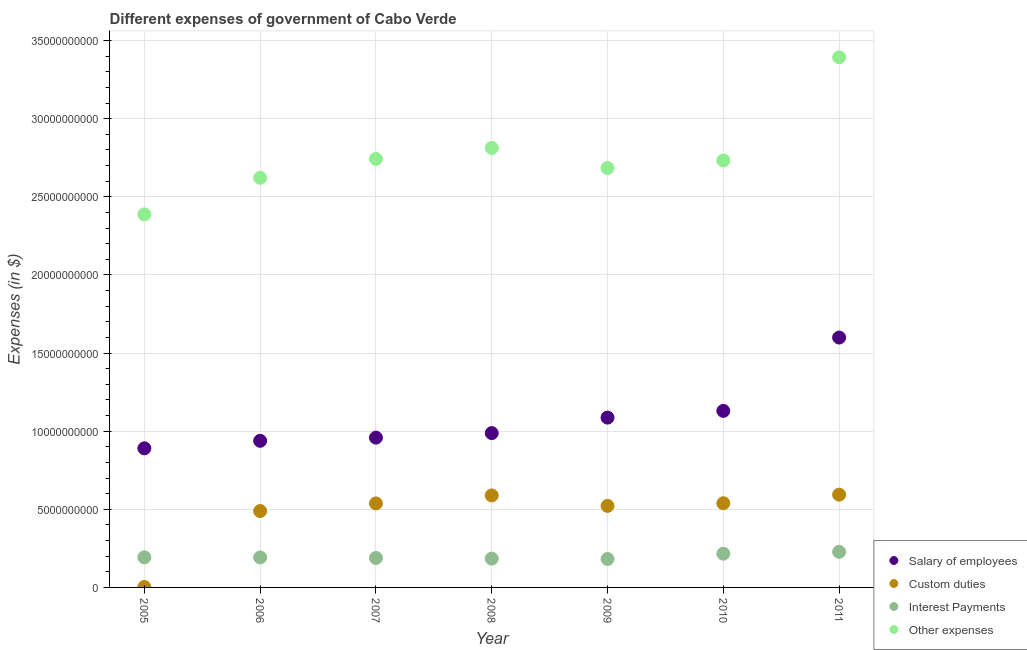Is the number of dotlines equal to the number of legend labels?
Give a very brief answer. Yes. What is the amount spent on interest payments in 2005?
Provide a short and direct response. 1.93e+09. Across all years, what is the maximum amount spent on salary of employees?
Give a very brief answer. 1.60e+1. Across all years, what is the minimum amount spent on custom duties?
Provide a succinct answer. 2.89e+07. In which year was the amount spent on other expenses minimum?
Give a very brief answer. 2005. What is the total amount spent on salary of employees in the graph?
Provide a succinct answer. 7.59e+1. What is the difference between the amount spent on custom duties in 2007 and that in 2011?
Make the answer very short. -5.61e+08. What is the difference between the amount spent on salary of employees in 2006 and the amount spent on interest payments in 2009?
Provide a short and direct response. 7.57e+09. What is the average amount spent on interest payments per year?
Your response must be concise. 1.98e+09. In the year 2006, what is the difference between the amount spent on interest payments and amount spent on custom duties?
Keep it short and to the point. -2.97e+09. What is the ratio of the amount spent on salary of employees in 2007 to that in 2010?
Keep it short and to the point. 0.85. Is the amount spent on other expenses in 2007 less than that in 2010?
Your answer should be compact. No. Is the difference between the amount spent on other expenses in 2007 and 2009 greater than the difference between the amount spent on custom duties in 2007 and 2009?
Offer a terse response. Yes. What is the difference between the highest and the second highest amount spent on salary of employees?
Offer a terse response. 4.70e+09. What is the difference between the highest and the lowest amount spent on interest payments?
Offer a terse response. 4.58e+08. Is the sum of the amount spent on custom duties in 2006 and 2009 greater than the maximum amount spent on interest payments across all years?
Your answer should be compact. Yes. Is it the case that in every year, the sum of the amount spent on salary of employees and amount spent on custom duties is greater than the amount spent on interest payments?
Give a very brief answer. Yes. Does the amount spent on custom duties monotonically increase over the years?
Your answer should be compact. No. Is the amount spent on custom duties strictly less than the amount spent on other expenses over the years?
Your answer should be very brief. Yes. What is the difference between two consecutive major ticks on the Y-axis?
Your response must be concise. 5.00e+09. Are the values on the major ticks of Y-axis written in scientific E-notation?
Ensure brevity in your answer.  No. Does the graph contain any zero values?
Keep it short and to the point. No. Where does the legend appear in the graph?
Your answer should be compact. Bottom right. How many legend labels are there?
Provide a succinct answer. 4. What is the title of the graph?
Your answer should be very brief. Different expenses of government of Cabo Verde. What is the label or title of the X-axis?
Give a very brief answer. Year. What is the label or title of the Y-axis?
Your response must be concise. Expenses (in $). What is the Expenses (in $) of Salary of employees in 2005?
Provide a succinct answer. 8.90e+09. What is the Expenses (in $) of Custom duties in 2005?
Keep it short and to the point. 2.89e+07. What is the Expenses (in $) of Interest Payments in 2005?
Your response must be concise. 1.93e+09. What is the Expenses (in $) in Other expenses in 2005?
Provide a short and direct response. 2.39e+1. What is the Expenses (in $) in Salary of employees in 2006?
Offer a terse response. 9.38e+09. What is the Expenses (in $) in Custom duties in 2006?
Your answer should be compact. 4.89e+09. What is the Expenses (in $) of Interest Payments in 2006?
Keep it short and to the point. 1.92e+09. What is the Expenses (in $) of Other expenses in 2006?
Your answer should be compact. 2.62e+1. What is the Expenses (in $) of Salary of employees in 2007?
Provide a succinct answer. 9.59e+09. What is the Expenses (in $) in Custom duties in 2007?
Provide a short and direct response. 5.38e+09. What is the Expenses (in $) of Interest Payments in 2007?
Your answer should be very brief. 1.89e+09. What is the Expenses (in $) of Other expenses in 2007?
Ensure brevity in your answer.  2.74e+1. What is the Expenses (in $) in Salary of employees in 2008?
Your answer should be very brief. 9.88e+09. What is the Expenses (in $) in Custom duties in 2008?
Give a very brief answer. 5.89e+09. What is the Expenses (in $) of Interest Payments in 2008?
Provide a short and direct response. 1.85e+09. What is the Expenses (in $) of Other expenses in 2008?
Provide a short and direct response. 2.81e+1. What is the Expenses (in $) in Salary of employees in 2009?
Ensure brevity in your answer.  1.09e+1. What is the Expenses (in $) in Custom duties in 2009?
Your answer should be very brief. 5.22e+09. What is the Expenses (in $) in Interest Payments in 2009?
Your response must be concise. 1.82e+09. What is the Expenses (in $) of Other expenses in 2009?
Ensure brevity in your answer.  2.68e+1. What is the Expenses (in $) in Salary of employees in 2010?
Provide a succinct answer. 1.13e+1. What is the Expenses (in $) of Custom duties in 2010?
Ensure brevity in your answer.  5.39e+09. What is the Expenses (in $) of Interest Payments in 2010?
Provide a short and direct response. 2.16e+09. What is the Expenses (in $) in Other expenses in 2010?
Provide a short and direct response. 2.73e+1. What is the Expenses (in $) of Salary of employees in 2011?
Your answer should be compact. 1.60e+1. What is the Expenses (in $) in Custom duties in 2011?
Your response must be concise. 5.94e+09. What is the Expenses (in $) in Interest Payments in 2011?
Offer a very short reply. 2.28e+09. What is the Expenses (in $) in Other expenses in 2011?
Keep it short and to the point. 3.39e+1. Across all years, what is the maximum Expenses (in $) in Salary of employees?
Give a very brief answer. 1.60e+1. Across all years, what is the maximum Expenses (in $) of Custom duties?
Offer a terse response. 5.94e+09. Across all years, what is the maximum Expenses (in $) in Interest Payments?
Your answer should be compact. 2.28e+09. Across all years, what is the maximum Expenses (in $) in Other expenses?
Your response must be concise. 3.39e+1. Across all years, what is the minimum Expenses (in $) of Salary of employees?
Your answer should be very brief. 8.90e+09. Across all years, what is the minimum Expenses (in $) in Custom duties?
Offer a terse response. 2.89e+07. Across all years, what is the minimum Expenses (in $) of Interest Payments?
Offer a terse response. 1.82e+09. Across all years, what is the minimum Expenses (in $) of Other expenses?
Provide a short and direct response. 2.39e+1. What is the total Expenses (in $) in Salary of employees in the graph?
Your answer should be compact. 7.59e+1. What is the total Expenses (in $) in Custom duties in the graph?
Keep it short and to the point. 3.27e+1. What is the total Expenses (in $) in Interest Payments in the graph?
Your answer should be very brief. 1.38e+1. What is the total Expenses (in $) of Other expenses in the graph?
Your answer should be very brief. 1.94e+11. What is the difference between the Expenses (in $) of Salary of employees in 2005 and that in 2006?
Keep it short and to the point. -4.81e+08. What is the difference between the Expenses (in $) of Custom duties in 2005 and that in 2006?
Provide a short and direct response. -4.86e+09. What is the difference between the Expenses (in $) in Interest Payments in 2005 and that in 2006?
Give a very brief answer. 7.14e+06. What is the difference between the Expenses (in $) of Other expenses in 2005 and that in 2006?
Make the answer very short. -2.34e+09. What is the difference between the Expenses (in $) of Salary of employees in 2005 and that in 2007?
Provide a short and direct response. -6.84e+08. What is the difference between the Expenses (in $) of Custom duties in 2005 and that in 2007?
Your answer should be very brief. -5.35e+09. What is the difference between the Expenses (in $) of Interest Payments in 2005 and that in 2007?
Your answer should be very brief. 4.18e+07. What is the difference between the Expenses (in $) of Other expenses in 2005 and that in 2007?
Provide a succinct answer. -3.55e+09. What is the difference between the Expenses (in $) in Salary of employees in 2005 and that in 2008?
Provide a succinct answer. -9.74e+08. What is the difference between the Expenses (in $) of Custom duties in 2005 and that in 2008?
Your answer should be compact. -5.86e+09. What is the difference between the Expenses (in $) of Interest Payments in 2005 and that in 2008?
Your answer should be compact. 8.17e+07. What is the difference between the Expenses (in $) in Other expenses in 2005 and that in 2008?
Your response must be concise. -4.25e+09. What is the difference between the Expenses (in $) in Salary of employees in 2005 and that in 2009?
Make the answer very short. -1.97e+09. What is the difference between the Expenses (in $) in Custom duties in 2005 and that in 2009?
Provide a succinct answer. -5.19e+09. What is the difference between the Expenses (in $) of Interest Payments in 2005 and that in 2009?
Keep it short and to the point. 1.09e+08. What is the difference between the Expenses (in $) in Other expenses in 2005 and that in 2009?
Give a very brief answer. -2.97e+09. What is the difference between the Expenses (in $) of Salary of employees in 2005 and that in 2010?
Ensure brevity in your answer.  -2.39e+09. What is the difference between the Expenses (in $) of Custom duties in 2005 and that in 2010?
Offer a terse response. -5.36e+09. What is the difference between the Expenses (in $) in Interest Payments in 2005 and that in 2010?
Keep it short and to the point. -2.32e+08. What is the difference between the Expenses (in $) of Other expenses in 2005 and that in 2010?
Ensure brevity in your answer.  -3.45e+09. What is the difference between the Expenses (in $) in Salary of employees in 2005 and that in 2011?
Offer a terse response. -7.09e+09. What is the difference between the Expenses (in $) of Custom duties in 2005 and that in 2011?
Your answer should be compact. -5.91e+09. What is the difference between the Expenses (in $) of Interest Payments in 2005 and that in 2011?
Make the answer very short. -3.49e+08. What is the difference between the Expenses (in $) of Other expenses in 2005 and that in 2011?
Your answer should be compact. -1.01e+1. What is the difference between the Expenses (in $) in Salary of employees in 2006 and that in 2007?
Offer a very short reply. -2.03e+08. What is the difference between the Expenses (in $) in Custom duties in 2006 and that in 2007?
Keep it short and to the point. -4.88e+08. What is the difference between the Expenses (in $) in Interest Payments in 2006 and that in 2007?
Provide a short and direct response. 3.47e+07. What is the difference between the Expenses (in $) of Other expenses in 2006 and that in 2007?
Offer a very short reply. -1.21e+09. What is the difference between the Expenses (in $) in Salary of employees in 2006 and that in 2008?
Provide a short and direct response. -4.93e+08. What is the difference between the Expenses (in $) in Custom duties in 2006 and that in 2008?
Give a very brief answer. -9.99e+08. What is the difference between the Expenses (in $) of Interest Payments in 2006 and that in 2008?
Your answer should be very brief. 7.45e+07. What is the difference between the Expenses (in $) in Other expenses in 2006 and that in 2008?
Ensure brevity in your answer.  -1.91e+09. What is the difference between the Expenses (in $) in Salary of employees in 2006 and that in 2009?
Your answer should be very brief. -1.49e+09. What is the difference between the Expenses (in $) of Custom duties in 2006 and that in 2009?
Your answer should be compact. -3.30e+08. What is the difference between the Expenses (in $) in Interest Payments in 2006 and that in 2009?
Provide a short and direct response. 1.02e+08. What is the difference between the Expenses (in $) in Other expenses in 2006 and that in 2009?
Make the answer very short. -6.27e+08. What is the difference between the Expenses (in $) in Salary of employees in 2006 and that in 2010?
Your response must be concise. -1.91e+09. What is the difference between the Expenses (in $) in Custom duties in 2006 and that in 2010?
Your response must be concise. -5.00e+08. What is the difference between the Expenses (in $) in Interest Payments in 2006 and that in 2010?
Provide a succinct answer. -2.39e+08. What is the difference between the Expenses (in $) of Other expenses in 2006 and that in 2010?
Give a very brief answer. -1.11e+09. What is the difference between the Expenses (in $) of Salary of employees in 2006 and that in 2011?
Provide a short and direct response. -6.61e+09. What is the difference between the Expenses (in $) of Custom duties in 2006 and that in 2011?
Offer a very short reply. -1.05e+09. What is the difference between the Expenses (in $) in Interest Payments in 2006 and that in 2011?
Make the answer very short. -3.56e+08. What is the difference between the Expenses (in $) in Other expenses in 2006 and that in 2011?
Provide a succinct answer. -7.71e+09. What is the difference between the Expenses (in $) of Salary of employees in 2007 and that in 2008?
Provide a short and direct response. -2.90e+08. What is the difference between the Expenses (in $) of Custom duties in 2007 and that in 2008?
Ensure brevity in your answer.  -5.12e+08. What is the difference between the Expenses (in $) of Interest Payments in 2007 and that in 2008?
Keep it short and to the point. 3.98e+07. What is the difference between the Expenses (in $) of Other expenses in 2007 and that in 2008?
Provide a succinct answer. -7.00e+08. What is the difference between the Expenses (in $) of Salary of employees in 2007 and that in 2009?
Make the answer very short. -1.28e+09. What is the difference between the Expenses (in $) in Custom duties in 2007 and that in 2009?
Offer a very short reply. 1.57e+08. What is the difference between the Expenses (in $) of Interest Payments in 2007 and that in 2009?
Provide a succinct answer. 6.70e+07. What is the difference between the Expenses (in $) in Other expenses in 2007 and that in 2009?
Give a very brief answer. 5.83e+08. What is the difference between the Expenses (in $) of Salary of employees in 2007 and that in 2010?
Provide a short and direct response. -1.71e+09. What is the difference between the Expenses (in $) in Custom duties in 2007 and that in 2010?
Give a very brief answer. -1.21e+07. What is the difference between the Expenses (in $) in Interest Payments in 2007 and that in 2010?
Ensure brevity in your answer.  -2.74e+08. What is the difference between the Expenses (in $) in Other expenses in 2007 and that in 2010?
Offer a terse response. 1.01e+08. What is the difference between the Expenses (in $) of Salary of employees in 2007 and that in 2011?
Offer a terse response. -6.41e+09. What is the difference between the Expenses (in $) of Custom duties in 2007 and that in 2011?
Ensure brevity in your answer.  -5.61e+08. What is the difference between the Expenses (in $) of Interest Payments in 2007 and that in 2011?
Your answer should be compact. -3.91e+08. What is the difference between the Expenses (in $) in Other expenses in 2007 and that in 2011?
Give a very brief answer. -6.50e+09. What is the difference between the Expenses (in $) of Salary of employees in 2008 and that in 2009?
Your answer should be very brief. -9.92e+08. What is the difference between the Expenses (in $) in Custom duties in 2008 and that in 2009?
Keep it short and to the point. 6.69e+08. What is the difference between the Expenses (in $) of Interest Payments in 2008 and that in 2009?
Provide a succinct answer. 2.72e+07. What is the difference between the Expenses (in $) in Other expenses in 2008 and that in 2009?
Your response must be concise. 1.28e+09. What is the difference between the Expenses (in $) in Salary of employees in 2008 and that in 2010?
Make the answer very short. -1.42e+09. What is the difference between the Expenses (in $) in Custom duties in 2008 and that in 2010?
Give a very brief answer. 5.00e+08. What is the difference between the Expenses (in $) of Interest Payments in 2008 and that in 2010?
Offer a terse response. -3.14e+08. What is the difference between the Expenses (in $) of Other expenses in 2008 and that in 2010?
Provide a succinct answer. 8.02e+08. What is the difference between the Expenses (in $) in Salary of employees in 2008 and that in 2011?
Your answer should be compact. -6.12e+09. What is the difference between the Expenses (in $) of Custom duties in 2008 and that in 2011?
Give a very brief answer. -4.94e+07. What is the difference between the Expenses (in $) of Interest Payments in 2008 and that in 2011?
Your response must be concise. -4.31e+08. What is the difference between the Expenses (in $) of Other expenses in 2008 and that in 2011?
Provide a short and direct response. -5.80e+09. What is the difference between the Expenses (in $) in Salary of employees in 2009 and that in 2010?
Your answer should be compact. -4.29e+08. What is the difference between the Expenses (in $) of Custom duties in 2009 and that in 2010?
Ensure brevity in your answer.  -1.69e+08. What is the difference between the Expenses (in $) of Interest Payments in 2009 and that in 2010?
Provide a succinct answer. -3.41e+08. What is the difference between the Expenses (in $) in Other expenses in 2009 and that in 2010?
Offer a terse response. -4.81e+08. What is the difference between the Expenses (in $) of Salary of employees in 2009 and that in 2011?
Offer a terse response. -5.12e+09. What is the difference between the Expenses (in $) of Custom duties in 2009 and that in 2011?
Provide a succinct answer. -7.19e+08. What is the difference between the Expenses (in $) of Interest Payments in 2009 and that in 2011?
Provide a short and direct response. -4.58e+08. What is the difference between the Expenses (in $) of Other expenses in 2009 and that in 2011?
Ensure brevity in your answer.  -7.08e+09. What is the difference between the Expenses (in $) of Salary of employees in 2010 and that in 2011?
Your answer should be compact. -4.70e+09. What is the difference between the Expenses (in $) of Custom duties in 2010 and that in 2011?
Give a very brief answer. -5.49e+08. What is the difference between the Expenses (in $) in Interest Payments in 2010 and that in 2011?
Offer a terse response. -1.17e+08. What is the difference between the Expenses (in $) in Other expenses in 2010 and that in 2011?
Ensure brevity in your answer.  -6.60e+09. What is the difference between the Expenses (in $) of Salary of employees in 2005 and the Expenses (in $) of Custom duties in 2006?
Offer a terse response. 4.01e+09. What is the difference between the Expenses (in $) in Salary of employees in 2005 and the Expenses (in $) in Interest Payments in 2006?
Provide a succinct answer. 6.98e+09. What is the difference between the Expenses (in $) of Salary of employees in 2005 and the Expenses (in $) of Other expenses in 2006?
Your answer should be very brief. -1.73e+1. What is the difference between the Expenses (in $) in Custom duties in 2005 and the Expenses (in $) in Interest Payments in 2006?
Your answer should be very brief. -1.89e+09. What is the difference between the Expenses (in $) in Custom duties in 2005 and the Expenses (in $) in Other expenses in 2006?
Make the answer very short. -2.62e+1. What is the difference between the Expenses (in $) in Interest Payments in 2005 and the Expenses (in $) in Other expenses in 2006?
Provide a succinct answer. -2.43e+1. What is the difference between the Expenses (in $) in Salary of employees in 2005 and the Expenses (in $) in Custom duties in 2007?
Your response must be concise. 3.53e+09. What is the difference between the Expenses (in $) of Salary of employees in 2005 and the Expenses (in $) of Interest Payments in 2007?
Your response must be concise. 7.02e+09. What is the difference between the Expenses (in $) in Salary of employees in 2005 and the Expenses (in $) in Other expenses in 2007?
Provide a short and direct response. -1.85e+1. What is the difference between the Expenses (in $) of Custom duties in 2005 and the Expenses (in $) of Interest Payments in 2007?
Offer a very short reply. -1.86e+09. What is the difference between the Expenses (in $) of Custom duties in 2005 and the Expenses (in $) of Other expenses in 2007?
Make the answer very short. -2.74e+1. What is the difference between the Expenses (in $) of Interest Payments in 2005 and the Expenses (in $) of Other expenses in 2007?
Provide a succinct answer. -2.55e+1. What is the difference between the Expenses (in $) in Salary of employees in 2005 and the Expenses (in $) in Custom duties in 2008?
Make the answer very short. 3.02e+09. What is the difference between the Expenses (in $) of Salary of employees in 2005 and the Expenses (in $) of Interest Payments in 2008?
Offer a very short reply. 7.06e+09. What is the difference between the Expenses (in $) of Salary of employees in 2005 and the Expenses (in $) of Other expenses in 2008?
Offer a very short reply. -1.92e+1. What is the difference between the Expenses (in $) in Custom duties in 2005 and the Expenses (in $) in Interest Payments in 2008?
Your response must be concise. -1.82e+09. What is the difference between the Expenses (in $) of Custom duties in 2005 and the Expenses (in $) of Other expenses in 2008?
Your answer should be compact. -2.81e+1. What is the difference between the Expenses (in $) in Interest Payments in 2005 and the Expenses (in $) in Other expenses in 2008?
Provide a succinct answer. -2.62e+1. What is the difference between the Expenses (in $) of Salary of employees in 2005 and the Expenses (in $) of Custom duties in 2009?
Ensure brevity in your answer.  3.68e+09. What is the difference between the Expenses (in $) of Salary of employees in 2005 and the Expenses (in $) of Interest Payments in 2009?
Make the answer very short. 7.09e+09. What is the difference between the Expenses (in $) of Salary of employees in 2005 and the Expenses (in $) of Other expenses in 2009?
Keep it short and to the point. -1.79e+1. What is the difference between the Expenses (in $) of Custom duties in 2005 and the Expenses (in $) of Interest Payments in 2009?
Offer a terse response. -1.79e+09. What is the difference between the Expenses (in $) of Custom duties in 2005 and the Expenses (in $) of Other expenses in 2009?
Provide a short and direct response. -2.68e+1. What is the difference between the Expenses (in $) of Interest Payments in 2005 and the Expenses (in $) of Other expenses in 2009?
Provide a short and direct response. -2.49e+1. What is the difference between the Expenses (in $) of Salary of employees in 2005 and the Expenses (in $) of Custom duties in 2010?
Offer a very short reply. 3.51e+09. What is the difference between the Expenses (in $) of Salary of employees in 2005 and the Expenses (in $) of Interest Payments in 2010?
Your answer should be very brief. 6.74e+09. What is the difference between the Expenses (in $) of Salary of employees in 2005 and the Expenses (in $) of Other expenses in 2010?
Ensure brevity in your answer.  -1.84e+1. What is the difference between the Expenses (in $) in Custom duties in 2005 and the Expenses (in $) in Interest Payments in 2010?
Make the answer very short. -2.13e+09. What is the difference between the Expenses (in $) in Custom duties in 2005 and the Expenses (in $) in Other expenses in 2010?
Offer a terse response. -2.73e+1. What is the difference between the Expenses (in $) in Interest Payments in 2005 and the Expenses (in $) in Other expenses in 2010?
Your answer should be very brief. -2.54e+1. What is the difference between the Expenses (in $) of Salary of employees in 2005 and the Expenses (in $) of Custom duties in 2011?
Offer a terse response. 2.97e+09. What is the difference between the Expenses (in $) of Salary of employees in 2005 and the Expenses (in $) of Interest Payments in 2011?
Your response must be concise. 6.63e+09. What is the difference between the Expenses (in $) of Salary of employees in 2005 and the Expenses (in $) of Other expenses in 2011?
Provide a short and direct response. -2.50e+1. What is the difference between the Expenses (in $) in Custom duties in 2005 and the Expenses (in $) in Interest Payments in 2011?
Your answer should be very brief. -2.25e+09. What is the difference between the Expenses (in $) in Custom duties in 2005 and the Expenses (in $) in Other expenses in 2011?
Make the answer very short. -3.39e+1. What is the difference between the Expenses (in $) of Interest Payments in 2005 and the Expenses (in $) of Other expenses in 2011?
Offer a terse response. -3.20e+1. What is the difference between the Expenses (in $) in Salary of employees in 2006 and the Expenses (in $) in Custom duties in 2007?
Your response must be concise. 4.01e+09. What is the difference between the Expenses (in $) in Salary of employees in 2006 and the Expenses (in $) in Interest Payments in 2007?
Your answer should be compact. 7.50e+09. What is the difference between the Expenses (in $) in Salary of employees in 2006 and the Expenses (in $) in Other expenses in 2007?
Ensure brevity in your answer.  -1.80e+1. What is the difference between the Expenses (in $) of Custom duties in 2006 and the Expenses (in $) of Interest Payments in 2007?
Keep it short and to the point. 3.00e+09. What is the difference between the Expenses (in $) of Custom duties in 2006 and the Expenses (in $) of Other expenses in 2007?
Keep it short and to the point. -2.25e+1. What is the difference between the Expenses (in $) of Interest Payments in 2006 and the Expenses (in $) of Other expenses in 2007?
Keep it short and to the point. -2.55e+1. What is the difference between the Expenses (in $) in Salary of employees in 2006 and the Expenses (in $) in Custom duties in 2008?
Your response must be concise. 3.50e+09. What is the difference between the Expenses (in $) in Salary of employees in 2006 and the Expenses (in $) in Interest Payments in 2008?
Make the answer very short. 7.54e+09. What is the difference between the Expenses (in $) of Salary of employees in 2006 and the Expenses (in $) of Other expenses in 2008?
Your response must be concise. -1.87e+1. What is the difference between the Expenses (in $) in Custom duties in 2006 and the Expenses (in $) in Interest Payments in 2008?
Make the answer very short. 3.04e+09. What is the difference between the Expenses (in $) of Custom duties in 2006 and the Expenses (in $) of Other expenses in 2008?
Provide a short and direct response. -2.32e+1. What is the difference between the Expenses (in $) in Interest Payments in 2006 and the Expenses (in $) in Other expenses in 2008?
Offer a terse response. -2.62e+1. What is the difference between the Expenses (in $) in Salary of employees in 2006 and the Expenses (in $) in Custom duties in 2009?
Keep it short and to the point. 4.16e+09. What is the difference between the Expenses (in $) of Salary of employees in 2006 and the Expenses (in $) of Interest Payments in 2009?
Offer a very short reply. 7.57e+09. What is the difference between the Expenses (in $) in Salary of employees in 2006 and the Expenses (in $) in Other expenses in 2009?
Keep it short and to the point. -1.75e+1. What is the difference between the Expenses (in $) in Custom duties in 2006 and the Expenses (in $) in Interest Payments in 2009?
Offer a very short reply. 3.07e+09. What is the difference between the Expenses (in $) of Custom duties in 2006 and the Expenses (in $) of Other expenses in 2009?
Provide a succinct answer. -2.20e+1. What is the difference between the Expenses (in $) of Interest Payments in 2006 and the Expenses (in $) of Other expenses in 2009?
Your answer should be compact. -2.49e+1. What is the difference between the Expenses (in $) of Salary of employees in 2006 and the Expenses (in $) of Custom duties in 2010?
Your response must be concise. 4.00e+09. What is the difference between the Expenses (in $) in Salary of employees in 2006 and the Expenses (in $) in Interest Payments in 2010?
Provide a succinct answer. 7.22e+09. What is the difference between the Expenses (in $) in Salary of employees in 2006 and the Expenses (in $) in Other expenses in 2010?
Provide a short and direct response. -1.79e+1. What is the difference between the Expenses (in $) in Custom duties in 2006 and the Expenses (in $) in Interest Payments in 2010?
Make the answer very short. 2.73e+09. What is the difference between the Expenses (in $) of Custom duties in 2006 and the Expenses (in $) of Other expenses in 2010?
Offer a terse response. -2.24e+1. What is the difference between the Expenses (in $) in Interest Payments in 2006 and the Expenses (in $) in Other expenses in 2010?
Give a very brief answer. -2.54e+1. What is the difference between the Expenses (in $) of Salary of employees in 2006 and the Expenses (in $) of Custom duties in 2011?
Your response must be concise. 3.45e+09. What is the difference between the Expenses (in $) of Salary of employees in 2006 and the Expenses (in $) of Interest Payments in 2011?
Offer a terse response. 7.11e+09. What is the difference between the Expenses (in $) of Salary of employees in 2006 and the Expenses (in $) of Other expenses in 2011?
Give a very brief answer. -2.45e+1. What is the difference between the Expenses (in $) in Custom duties in 2006 and the Expenses (in $) in Interest Payments in 2011?
Give a very brief answer. 2.61e+09. What is the difference between the Expenses (in $) in Custom duties in 2006 and the Expenses (in $) in Other expenses in 2011?
Ensure brevity in your answer.  -2.90e+1. What is the difference between the Expenses (in $) in Interest Payments in 2006 and the Expenses (in $) in Other expenses in 2011?
Your answer should be very brief. -3.20e+1. What is the difference between the Expenses (in $) in Salary of employees in 2007 and the Expenses (in $) in Custom duties in 2008?
Provide a short and direct response. 3.70e+09. What is the difference between the Expenses (in $) in Salary of employees in 2007 and the Expenses (in $) in Interest Payments in 2008?
Your answer should be compact. 7.74e+09. What is the difference between the Expenses (in $) of Salary of employees in 2007 and the Expenses (in $) of Other expenses in 2008?
Your answer should be compact. -1.85e+1. What is the difference between the Expenses (in $) in Custom duties in 2007 and the Expenses (in $) in Interest Payments in 2008?
Provide a short and direct response. 3.53e+09. What is the difference between the Expenses (in $) of Custom duties in 2007 and the Expenses (in $) of Other expenses in 2008?
Make the answer very short. -2.28e+1. What is the difference between the Expenses (in $) of Interest Payments in 2007 and the Expenses (in $) of Other expenses in 2008?
Offer a terse response. -2.62e+1. What is the difference between the Expenses (in $) of Salary of employees in 2007 and the Expenses (in $) of Custom duties in 2009?
Provide a short and direct response. 4.37e+09. What is the difference between the Expenses (in $) in Salary of employees in 2007 and the Expenses (in $) in Interest Payments in 2009?
Ensure brevity in your answer.  7.77e+09. What is the difference between the Expenses (in $) in Salary of employees in 2007 and the Expenses (in $) in Other expenses in 2009?
Keep it short and to the point. -1.73e+1. What is the difference between the Expenses (in $) in Custom duties in 2007 and the Expenses (in $) in Interest Payments in 2009?
Keep it short and to the point. 3.56e+09. What is the difference between the Expenses (in $) in Custom duties in 2007 and the Expenses (in $) in Other expenses in 2009?
Make the answer very short. -2.15e+1. What is the difference between the Expenses (in $) in Interest Payments in 2007 and the Expenses (in $) in Other expenses in 2009?
Your answer should be compact. -2.50e+1. What is the difference between the Expenses (in $) in Salary of employees in 2007 and the Expenses (in $) in Custom duties in 2010?
Your answer should be compact. 4.20e+09. What is the difference between the Expenses (in $) of Salary of employees in 2007 and the Expenses (in $) of Interest Payments in 2010?
Keep it short and to the point. 7.43e+09. What is the difference between the Expenses (in $) in Salary of employees in 2007 and the Expenses (in $) in Other expenses in 2010?
Make the answer very short. -1.77e+1. What is the difference between the Expenses (in $) in Custom duties in 2007 and the Expenses (in $) in Interest Payments in 2010?
Your answer should be very brief. 3.22e+09. What is the difference between the Expenses (in $) of Custom duties in 2007 and the Expenses (in $) of Other expenses in 2010?
Ensure brevity in your answer.  -2.19e+1. What is the difference between the Expenses (in $) of Interest Payments in 2007 and the Expenses (in $) of Other expenses in 2010?
Your answer should be very brief. -2.54e+1. What is the difference between the Expenses (in $) in Salary of employees in 2007 and the Expenses (in $) in Custom duties in 2011?
Provide a short and direct response. 3.65e+09. What is the difference between the Expenses (in $) in Salary of employees in 2007 and the Expenses (in $) in Interest Payments in 2011?
Ensure brevity in your answer.  7.31e+09. What is the difference between the Expenses (in $) of Salary of employees in 2007 and the Expenses (in $) of Other expenses in 2011?
Give a very brief answer. -2.43e+1. What is the difference between the Expenses (in $) in Custom duties in 2007 and the Expenses (in $) in Interest Payments in 2011?
Provide a short and direct response. 3.10e+09. What is the difference between the Expenses (in $) in Custom duties in 2007 and the Expenses (in $) in Other expenses in 2011?
Give a very brief answer. -2.86e+1. What is the difference between the Expenses (in $) in Interest Payments in 2007 and the Expenses (in $) in Other expenses in 2011?
Give a very brief answer. -3.20e+1. What is the difference between the Expenses (in $) of Salary of employees in 2008 and the Expenses (in $) of Custom duties in 2009?
Your response must be concise. 4.66e+09. What is the difference between the Expenses (in $) of Salary of employees in 2008 and the Expenses (in $) of Interest Payments in 2009?
Your response must be concise. 8.06e+09. What is the difference between the Expenses (in $) of Salary of employees in 2008 and the Expenses (in $) of Other expenses in 2009?
Provide a succinct answer. -1.70e+1. What is the difference between the Expenses (in $) of Custom duties in 2008 and the Expenses (in $) of Interest Payments in 2009?
Make the answer very short. 4.07e+09. What is the difference between the Expenses (in $) of Custom duties in 2008 and the Expenses (in $) of Other expenses in 2009?
Keep it short and to the point. -2.10e+1. What is the difference between the Expenses (in $) of Interest Payments in 2008 and the Expenses (in $) of Other expenses in 2009?
Offer a terse response. -2.50e+1. What is the difference between the Expenses (in $) in Salary of employees in 2008 and the Expenses (in $) in Custom duties in 2010?
Make the answer very short. 4.49e+09. What is the difference between the Expenses (in $) in Salary of employees in 2008 and the Expenses (in $) in Interest Payments in 2010?
Provide a succinct answer. 7.72e+09. What is the difference between the Expenses (in $) of Salary of employees in 2008 and the Expenses (in $) of Other expenses in 2010?
Offer a terse response. -1.74e+1. What is the difference between the Expenses (in $) in Custom duties in 2008 and the Expenses (in $) in Interest Payments in 2010?
Give a very brief answer. 3.73e+09. What is the difference between the Expenses (in $) of Custom duties in 2008 and the Expenses (in $) of Other expenses in 2010?
Offer a very short reply. -2.14e+1. What is the difference between the Expenses (in $) in Interest Payments in 2008 and the Expenses (in $) in Other expenses in 2010?
Make the answer very short. -2.55e+1. What is the difference between the Expenses (in $) of Salary of employees in 2008 and the Expenses (in $) of Custom duties in 2011?
Give a very brief answer. 3.94e+09. What is the difference between the Expenses (in $) in Salary of employees in 2008 and the Expenses (in $) in Interest Payments in 2011?
Ensure brevity in your answer.  7.60e+09. What is the difference between the Expenses (in $) of Salary of employees in 2008 and the Expenses (in $) of Other expenses in 2011?
Ensure brevity in your answer.  -2.41e+1. What is the difference between the Expenses (in $) of Custom duties in 2008 and the Expenses (in $) of Interest Payments in 2011?
Ensure brevity in your answer.  3.61e+09. What is the difference between the Expenses (in $) of Custom duties in 2008 and the Expenses (in $) of Other expenses in 2011?
Your response must be concise. -2.80e+1. What is the difference between the Expenses (in $) in Interest Payments in 2008 and the Expenses (in $) in Other expenses in 2011?
Ensure brevity in your answer.  -3.21e+1. What is the difference between the Expenses (in $) in Salary of employees in 2009 and the Expenses (in $) in Custom duties in 2010?
Provide a short and direct response. 5.48e+09. What is the difference between the Expenses (in $) in Salary of employees in 2009 and the Expenses (in $) in Interest Payments in 2010?
Your response must be concise. 8.71e+09. What is the difference between the Expenses (in $) in Salary of employees in 2009 and the Expenses (in $) in Other expenses in 2010?
Your answer should be very brief. -1.65e+1. What is the difference between the Expenses (in $) in Custom duties in 2009 and the Expenses (in $) in Interest Payments in 2010?
Provide a short and direct response. 3.06e+09. What is the difference between the Expenses (in $) of Custom duties in 2009 and the Expenses (in $) of Other expenses in 2010?
Make the answer very short. -2.21e+1. What is the difference between the Expenses (in $) in Interest Payments in 2009 and the Expenses (in $) in Other expenses in 2010?
Offer a very short reply. -2.55e+1. What is the difference between the Expenses (in $) in Salary of employees in 2009 and the Expenses (in $) in Custom duties in 2011?
Make the answer very short. 4.93e+09. What is the difference between the Expenses (in $) in Salary of employees in 2009 and the Expenses (in $) in Interest Payments in 2011?
Ensure brevity in your answer.  8.59e+09. What is the difference between the Expenses (in $) in Salary of employees in 2009 and the Expenses (in $) in Other expenses in 2011?
Give a very brief answer. -2.31e+1. What is the difference between the Expenses (in $) of Custom duties in 2009 and the Expenses (in $) of Interest Payments in 2011?
Your answer should be very brief. 2.94e+09. What is the difference between the Expenses (in $) in Custom duties in 2009 and the Expenses (in $) in Other expenses in 2011?
Offer a terse response. -2.87e+1. What is the difference between the Expenses (in $) of Interest Payments in 2009 and the Expenses (in $) of Other expenses in 2011?
Offer a terse response. -3.21e+1. What is the difference between the Expenses (in $) in Salary of employees in 2010 and the Expenses (in $) in Custom duties in 2011?
Provide a succinct answer. 5.36e+09. What is the difference between the Expenses (in $) in Salary of employees in 2010 and the Expenses (in $) in Interest Payments in 2011?
Your response must be concise. 9.02e+09. What is the difference between the Expenses (in $) in Salary of employees in 2010 and the Expenses (in $) in Other expenses in 2011?
Your response must be concise. -2.26e+1. What is the difference between the Expenses (in $) in Custom duties in 2010 and the Expenses (in $) in Interest Payments in 2011?
Make the answer very short. 3.11e+09. What is the difference between the Expenses (in $) of Custom duties in 2010 and the Expenses (in $) of Other expenses in 2011?
Your answer should be very brief. -2.85e+1. What is the difference between the Expenses (in $) in Interest Payments in 2010 and the Expenses (in $) in Other expenses in 2011?
Your response must be concise. -3.18e+1. What is the average Expenses (in $) in Salary of employees per year?
Your answer should be compact. 1.08e+1. What is the average Expenses (in $) of Custom duties per year?
Keep it short and to the point. 4.68e+09. What is the average Expenses (in $) of Interest Payments per year?
Make the answer very short. 1.98e+09. What is the average Expenses (in $) of Other expenses per year?
Provide a short and direct response. 2.77e+1. In the year 2005, what is the difference between the Expenses (in $) of Salary of employees and Expenses (in $) of Custom duties?
Make the answer very short. 8.87e+09. In the year 2005, what is the difference between the Expenses (in $) of Salary of employees and Expenses (in $) of Interest Payments?
Your answer should be very brief. 6.98e+09. In the year 2005, what is the difference between the Expenses (in $) of Salary of employees and Expenses (in $) of Other expenses?
Your response must be concise. -1.50e+1. In the year 2005, what is the difference between the Expenses (in $) in Custom duties and Expenses (in $) in Interest Payments?
Make the answer very short. -1.90e+09. In the year 2005, what is the difference between the Expenses (in $) in Custom duties and Expenses (in $) in Other expenses?
Offer a terse response. -2.38e+1. In the year 2005, what is the difference between the Expenses (in $) of Interest Payments and Expenses (in $) of Other expenses?
Offer a terse response. -2.19e+1. In the year 2006, what is the difference between the Expenses (in $) of Salary of employees and Expenses (in $) of Custom duties?
Offer a terse response. 4.50e+09. In the year 2006, what is the difference between the Expenses (in $) of Salary of employees and Expenses (in $) of Interest Payments?
Your response must be concise. 7.46e+09. In the year 2006, what is the difference between the Expenses (in $) of Salary of employees and Expenses (in $) of Other expenses?
Make the answer very short. -1.68e+1. In the year 2006, what is the difference between the Expenses (in $) in Custom duties and Expenses (in $) in Interest Payments?
Make the answer very short. 2.97e+09. In the year 2006, what is the difference between the Expenses (in $) in Custom duties and Expenses (in $) in Other expenses?
Offer a terse response. -2.13e+1. In the year 2006, what is the difference between the Expenses (in $) in Interest Payments and Expenses (in $) in Other expenses?
Provide a short and direct response. -2.43e+1. In the year 2007, what is the difference between the Expenses (in $) in Salary of employees and Expenses (in $) in Custom duties?
Ensure brevity in your answer.  4.21e+09. In the year 2007, what is the difference between the Expenses (in $) in Salary of employees and Expenses (in $) in Interest Payments?
Offer a terse response. 7.70e+09. In the year 2007, what is the difference between the Expenses (in $) in Salary of employees and Expenses (in $) in Other expenses?
Make the answer very short. -1.78e+1. In the year 2007, what is the difference between the Expenses (in $) in Custom duties and Expenses (in $) in Interest Payments?
Provide a succinct answer. 3.49e+09. In the year 2007, what is the difference between the Expenses (in $) of Custom duties and Expenses (in $) of Other expenses?
Provide a succinct answer. -2.21e+1. In the year 2007, what is the difference between the Expenses (in $) of Interest Payments and Expenses (in $) of Other expenses?
Provide a short and direct response. -2.55e+1. In the year 2008, what is the difference between the Expenses (in $) of Salary of employees and Expenses (in $) of Custom duties?
Your answer should be compact. 3.99e+09. In the year 2008, what is the difference between the Expenses (in $) in Salary of employees and Expenses (in $) in Interest Payments?
Your answer should be very brief. 8.03e+09. In the year 2008, what is the difference between the Expenses (in $) of Salary of employees and Expenses (in $) of Other expenses?
Give a very brief answer. -1.83e+1. In the year 2008, what is the difference between the Expenses (in $) in Custom duties and Expenses (in $) in Interest Payments?
Provide a short and direct response. 4.04e+09. In the year 2008, what is the difference between the Expenses (in $) of Custom duties and Expenses (in $) of Other expenses?
Ensure brevity in your answer.  -2.22e+1. In the year 2008, what is the difference between the Expenses (in $) of Interest Payments and Expenses (in $) of Other expenses?
Provide a succinct answer. -2.63e+1. In the year 2009, what is the difference between the Expenses (in $) in Salary of employees and Expenses (in $) in Custom duties?
Provide a succinct answer. 5.65e+09. In the year 2009, what is the difference between the Expenses (in $) in Salary of employees and Expenses (in $) in Interest Payments?
Offer a terse response. 9.05e+09. In the year 2009, what is the difference between the Expenses (in $) in Salary of employees and Expenses (in $) in Other expenses?
Provide a succinct answer. -1.60e+1. In the year 2009, what is the difference between the Expenses (in $) of Custom duties and Expenses (in $) of Interest Payments?
Make the answer very short. 3.40e+09. In the year 2009, what is the difference between the Expenses (in $) in Custom duties and Expenses (in $) in Other expenses?
Keep it short and to the point. -2.16e+1. In the year 2009, what is the difference between the Expenses (in $) in Interest Payments and Expenses (in $) in Other expenses?
Your answer should be compact. -2.50e+1. In the year 2010, what is the difference between the Expenses (in $) of Salary of employees and Expenses (in $) of Custom duties?
Ensure brevity in your answer.  5.91e+09. In the year 2010, what is the difference between the Expenses (in $) of Salary of employees and Expenses (in $) of Interest Payments?
Provide a short and direct response. 9.14e+09. In the year 2010, what is the difference between the Expenses (in $) in Salary of employees and Expenses (in $) in Other expenses?
Give a very brief answer. -1.60e+1. In the year 2010, what is the difference between the Expenses (in $) of Custom duties and Expenses (in $) of Interest Payments?
Keep it short and to the point. 3.23e+09. In the year 2010, what is the difference between the Expenses (in $) in Custom duties and Expenses (in $) in Other expenses?
Give a very brief answer. -2.19e+1. In the year 2010, what is the difference between the Expenses (in $) of Interest Payments and Expenses (in $) of Other expenses?
Make the answer very short. -2.52e+1. In the year 2011, what is the difference between the Expenses (in $) in Salary of employees and Expenses (in $) in Custom duties?
Make the answer very short. 1.01e+1. In the year 2011, what is the difference between the Expenses (in $) of Salary of employees and Expenses (in $) of Interest Payments?
Ensure brevity in your answer.  1.37e+1. In the year 2011, what is the difference between the Expenses (in $) in Salary of employees and Expenses (in $) in Other expenses?
Your answer should be compact. -1.79e+1. In the year 2011, what is the difference between the Expenses (in $) in Custom duties and Expenses (in $) in Interest Payments?
Your answer should be very brief. 3.66e+09. In the year 2011, what is the difference between the Expenses (in $) in Custom duties and Expenses (in $) in Other expenses?
Your answer should be very brief. -2.80e+1. In the year 2011, what is the difference between the Expenses (in $) of Interest Payments and Expenses (in $) of Other expenses?
Your answer should be very brief. -3.17e+1. What is the ratio of the Expenses (in $) of Salary of employees in 2005 to that in 2006?
Make the answer very short. 0.95. What is the ratio of the Expenses (in $) in Custom duties in 2005 to that in 2006?
Your response must be concise. 0.01. What is the ratio of the Expenses (in $) of Other expenses in 2005 to that in 2006?
Your response must be concise. 0.91. What is the ratio of the Expenses (in $) in Salary of employees in 2005 to that in 2007?
Ensure brevity in your answer.  0.93. What is the ratio of the Expenses (in $) in Custom duties in 2005 to that in 2007?
Offer a very short reply. 0.01. What is the ratio of the Expenses (in $) of Interest Payments in 2005 to that in 2007?
Make the answer very short. 1.02. What is the ratio of the Expenses (in $) in Other expenses in 2005 to that in 2007?
Offer a terse response. 0.87. What is the ratio of the Expenses (in $) in Salary of employees in 2005 to that in 2008?
Ensure brevity in your answer.  0.9. What is the ratio of the Expenses (in $) in Custom duties in 2005 to that in 2008?
Your response must be concise. 0. What is the ratio of the Expenses (in $) in Interest Payments in 2005 to that in 2008?
Make the answer very short. 1.04. What is the ratio of the Expenses (in $) of Other expenses in 2005 to that in 2008?
Ensure brevity in your answer.  0.85. What is the ratio of the Expenses (in $) of Salary of employees in 2005 to that in 2009?
Keep it short and to the point. 0.82. What is the ratio of the Expenses (in $) of Custom duties in 2005 to that in 2009?
Offer a terse response. 0.01. What is the ratio of the Expenses (in $) of Interest Payments in 2005 to that in 2009?
Ensure brevity in your answer.  1.06. What is the ratio of the Expenses (in $) of Other expenses in 2005 to that in 2009?
Ensure brevity in your answer.  0.89. What is the ratio of the Expenses (in $) of Salary of employees in 2005 to that in 2010?
Offer a very short reply. 0.79. What is the ratio of the Expenses (in $) of Custom duties in 2005 to that in 2010?
Provide a short and direct response. 0.01. What is the ratio of the Expenses (in $) of Interest Payments in 2005 to that in 2010?
Offer a terse response. 0.89. What is the ratio of the Expenses (in $) in Other expenses in 2005 to that in 2010?
Your answer should be very brief. 0.87. What is the ratio of the Expenses (in $) of Salary of employees in 2005 to that in 2011?
Your answer should be very brief. 0.56. What is the ratio of the Expenses (in $) of Custom duties in 2005 to that in 2011?
Give a very brief answer. 0. What is the ratio of the Expenses (in $) of Interest Payments in 2005 to that in 2011?
Provide a succinct answer. 0.85. What is the ratio of the Expenses (in $) in Other expenses in 2005 to that in 2011?
Offer a terse response. 0.7. What is the ratio of the Expenses (in $) of Salary of employees in 2006 to that in 2007?
Keep it short and to the point. 0.98. What is the ratio of the Expenses (in $) in Custom duties in 2006 to that in 2007?
Keep it short and to the point. 0.91. What is the ratio of the Expenses (in $) of Interest Payments in 2006 to that in 2007?
Your answer should be compact. 1.02. What is the ratio of the Expenses (in $) in Other expenses in 2006 to that in 2007?
Offer a very short reply. 0.96. What is the ratio of the Expenses (in $) of Salary of employees in 2006 to that in 2008?
Offer a very short reply. 0.95. What is the ratio of the Expenses (in $) in Custom duties in 2006 to that in 2008?
Provide a succinct answer. 0.83. What is the ratio of the Expenses (in $) in Interest Payments in 2006 to that in 2008?
Offer a terse response. 1.04. What is the ratio of the Expenses (in $) in Other expenses in 2006 to that in 2008?
Keep it short and to the point. 0.93. What is the ratio of the Expenses (in $) in Salary of employees in 2006 to that in 2009?
Keep it short and to the point. 0.86. What is the ratio of the Expenses (in $) in Custom duties in 2006 to that in 2009?
Provide a succinct answer. 0.94. What is the ratio of the Expenses (in $) in Interest Payments in 2006 to that in 2009?
Make the answer very short. 1.06. What is the ratio of the Expenses (in $) of Other expenses in 2006 to that in 2009?
Your response must be concise. 0.98. What is the ratio of the Expenses (in $) in Salary of employees in 2006 to that in 2010?
Provide a succinct answer. 0.83. What is the ratio of the Expenses (in $) of Custom duties in 2006 to that in 2010?
Offer a very short reply. 0.91. What is the ratio of the Expenses (in $) of Interest Payments in 2006 to that in 2010?
Ensure brevity in your answer.  0.89. What is the ratio of the Expenses (in $) in Other expenses in 2006 to that in 2010?
Offer a terse response. 0.96. What is the ratio of the Expenses (in $) in Salary of employees in 2006 to that in 2011?
Keep it short and to the point. 0.59. What is the ratio of the Expenses (in $) in Custom duties in 2006 to that in 2011?
Give a very brief answer. 0.82. What is the ratio of the Expenses (in $) of Interest Payments in 2006 to that in 2011?
Provide a succinct answer. 0.84. What is the ratio of the Expenses (in $) of Other expenses in 2006 to that in 2011?
Make the answer very short. 0.77. What is the ratio of the Expenses (in $) of Salary of employees in 2007 to that in 2008?
Provide a succinct answer. 0.97. What is the ratio of the Expenses (in $) of Custom duties in 2007 to that in 2008?
Give a very brief answer. 0.91. What is the ratio of the Expenses (in $) in Interest Payments in 2007 to that in 2008?
Keep it short and to the point. 1.02. What is the ratio of the Expenses (in $) in Other expenses in 2007 to that in 2008?
Provide a succinct answer. 0.98. What is the ratio of the Expenses (in $) in Salary of employees in 2007 to that in 2009?
Provide a succinct answer. 0.88. What is the ratio of the Expenses (in $) in Custom duties in 2007 to that in 2009?
Keep it short and to the point. 1.03. What is the ratio of the Expenses (in $) of Interest Payments in 2007 to that in 2009?
Ensure brevity in your answer.  1.04. What is the ratio of the Expenses (in $) of Other expenses in 2007 to that in 2009?
Offer a very short reply. 1.02. What is the ratio of the Expenses (in $) in Salary of employees in 2007 to that in 2010?
Keep it short and to the point. 0.85. What is the ratio of the Expenses (in $) of Custom duties in 2007 to that in 2010?
Offer a terse response. 1. What is the ratio of the Expenses (in $) of Interest Payments in 2007 to that in 2010?
Your answer should be compact. 0.87. What is the ratio of the Expenses (in $) of Salary of employees in 2007 to that in 2011?
Your answer should be compact. 0.6. What is the ratio of the Expenses (in $) in Custom duties in 2007 to that in 2011?
Ensure brevity in your answer.  0.91. What is the ratio of the Expenses (in $) of Interest Payments in 2007 to that in 2011?
Ensure brevity in your answer.  0.83. What is the ratio of the Expenses (in $) in Other expenses in 2007 to that in 2011?
Your answer should be very brief. 0.81. What is the ratio of the Expenses (in $) of Salary of employees in 2008 to that in 2009?
Your answer should be very brief. 0.91. What is the ratio of the Expenses (in $) of Custom duties in 2008 to that in 2009?
Keep it short and to the point. 1.13. What is the ratio of the Expenses (in $) in Interest Payments in 2008 to that in 2009?
Give a very brief answer. 1.01. What is the ratio of the Expenses (in $) in Other expenses in 2008 to that in 2009?
Provide a succinct answer. 1.05. What is the ratio of the Expenses (in $) of Salary of employees in 2008 to that in 2010?
Ensure brevity in your answer.  0.87. What is the ratio of the Expenses (in $) in Custom duties in 2008 to that in 2010?
Make the answer very short. 1.09. What is the ratio of the Expenses (in $) in Interest Payments in 2008 to that in 2010?
Keep it short and to the point. 0.85. What is the ratio of the Expenses (in $) of Other expenses in 2008 to that in 2010?
Your response must be concise. 1.03. What is the ratio of the Expenses (in $) of Salary of employees in 2008 to that in 2011?
Offer a very short reply. 0.62. What is the ratio of the Expenses (in $) in Custom duties in 2008 to that in 2011?
Provide a short and direct response. 0.99. What is the ratio of the Expenses (in $) of Interest Payments in 2008 to that in 2011?
Offer a terse response. 0.81. What is the ratio of the Expenses (in $) in Other expenses in 2008 to that in 2011?
Provide a succinct answer. 0.83. What is the ratio of the Expenses (in $) of Salary of employees in 2009 to that in 2010?
Make the answer very short. 0.96. What is the ratio of the Expenses (in $) in Custom duties in 2009 to that in 2010?
Provide a succinct answer. 0.97. What is the ratio of the Expenses (in $) of Interest Payments in 2009 to that in 2010?
Give a very brief answer. 0.84. What is the ratio of the Expenses (in $) in Other expenses in 2009 to that in 2010?
Provide a short and direct response. 0.98. What is the ratio of the Expenses (in $) in Salary of employees in 2009 to that in 2011?
Offer a very short reply. 0.68. What is the ratio of the Expenses (in $) in Custom duties in 2009 to that in 2011?
Keep it short and to the point. 0.88. What is the ratio of the Expenses (in $) in Interest Payments in 2009 to that in 2011?
Make the answer very short. 0.8. What is the ratio of the Expenses (in $) in Other expenses in 2009 to that in 2011?
Your answer should be compact. 0.79. What is the ratio of the Expenses (in $) in Salary of employees in 2010 to that in 2011?
Provide a succinct answer. 0.71. What is the ratio of the Expenses (in $) in Custom duties in 2010 to that in 2011?
Give a very brief answer. 0.91. What is the ratio of the Expenses (in $) of Interest Payments in 2010 to that in 2011?
Offer a very short reply. 0.95. What is the ratio of the Expenses (in $) in Other expenses in 2010 to that in 2011?
Provide a short and direct response. 0.81. What is the difference between the highest and the second highest Expenses (in $) of Salary of employees?
Offer a very short reply. 4.70e+09. What is the difference between the highest and the second highest Expenses (in $) of Custom duties?
Your answer should be very brief. 4.94e+07. What is the difference between the highest and the second highest Expenses (in $) in Interest Payments?
Your answer should be compact. 1.17e+08. What is the difference between the highest and the second highest Expenses (in $) in Other expenses?
Give a very brief answer. 5.80e+09. What is the difference between the highest and the lowest Expenses (in $) in Salary of employees?
Provide a succinct answer. 7.09e+09. What is the difference between the highest and the lowest Expenses (in $) in Custom duties?
Give a very brief answer. 5.91e+09. What is the difference between the highest and the lowest Expenses (in $) in Interest Payments?
Offer a very short reply. 4.58e+08. What is the difference between the highest and the lowest Expenses (in $) of Other expenses?
Provide a short and direct response. 1.01e+1. 